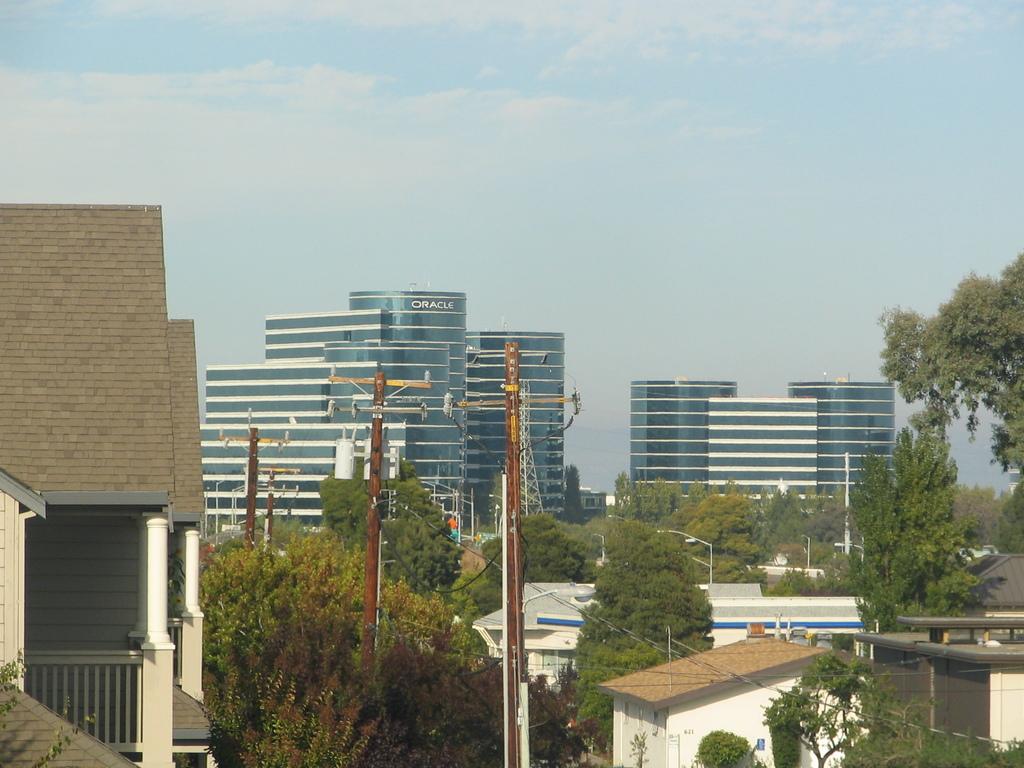Which company owns the building in the middle?
Make the answer very short. Oracle. 